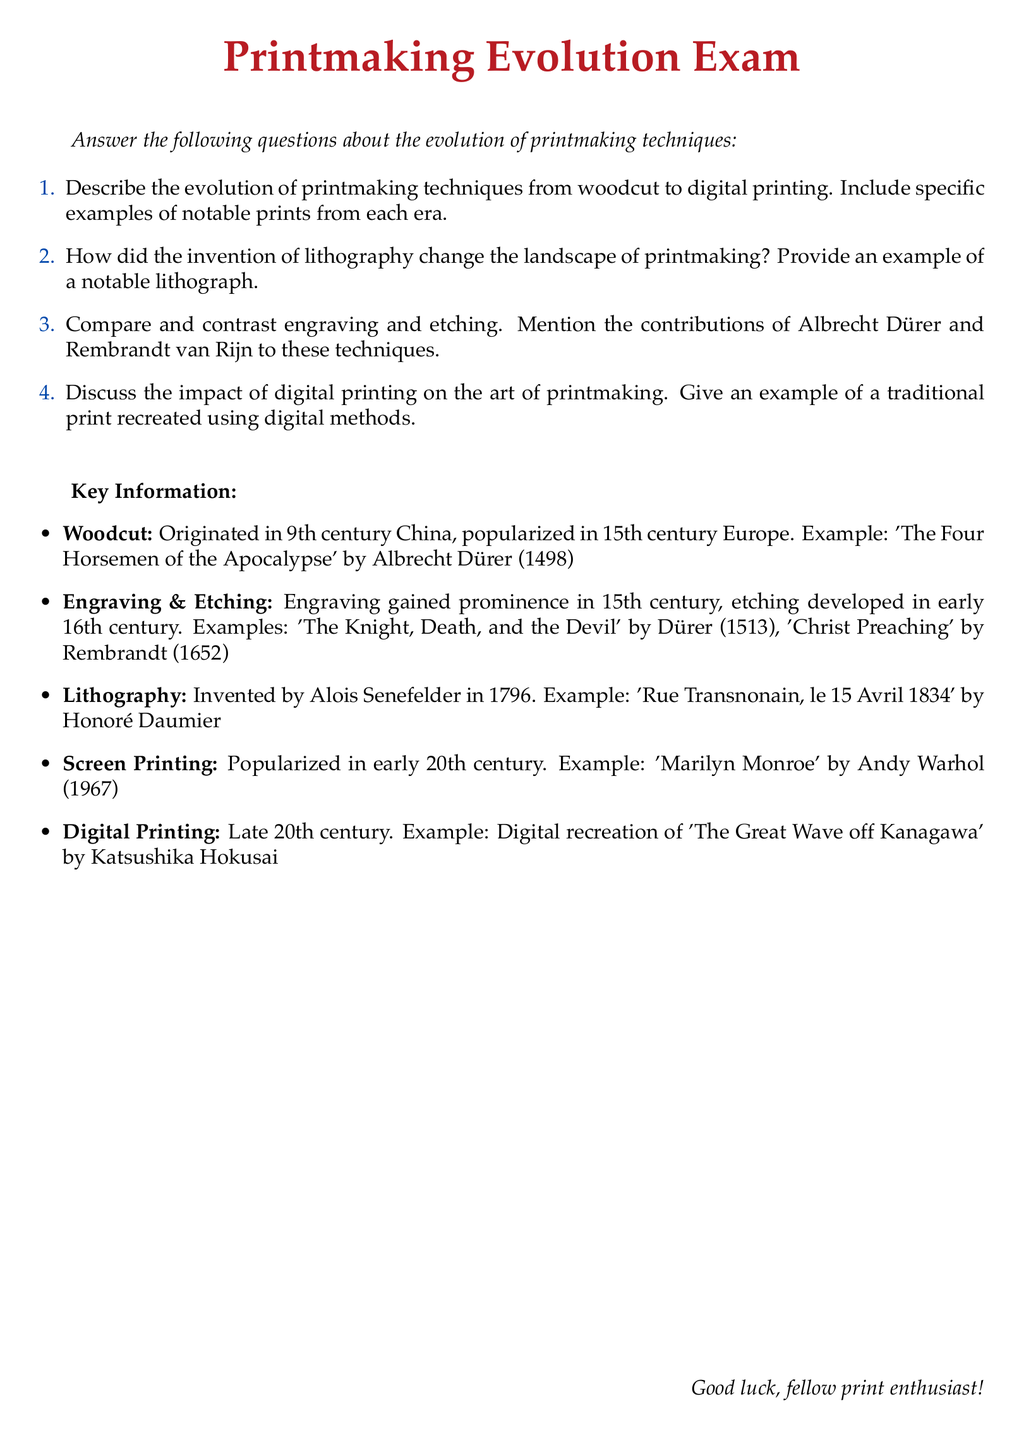What is the title of the exam? The title is indicated in the document as the main heading.
Answer: Printmaking Evolution Exam In what century did woodcut originate? The document specifies the origin time frame for woodcut in relation to Chinese history.
Answer: 9th century Who created the lithograph 'Rue Transnonain, le 15 Avril 1834'? The document names the artist associated with this notable lithograph.
Answer: Honoré Daumier Which printmaking technique was popularized in the early 20th century? The document highlights the specific technique that gained popularity in this timeframe.
Answer: Screen Printing What notable print did Albrecht Dürer create in 1513? The document lists this print as an example related to engraving and Dürer's contributions.
Answer: The Knight, Death, and the Devil What year was lithography invented? The document provides the invention date related to lithography in the context of history.
Answer: 1796 Which artist is known for the digital recreation of 'The Great Wave off Kanagawa'? The document assigns this work to a specific artist known for recreating it digitally.
Answer: Katsushika Hokusai What technique developed in the early 16th century? The document notes the timeline for the emergence of this printmaking technique.
Answer: Etching Which print by Andy Warhol is mentioned in the exam? The document identifies a specific print associated with Warhol and screen printing.
Answer: Marilyn Monroe 